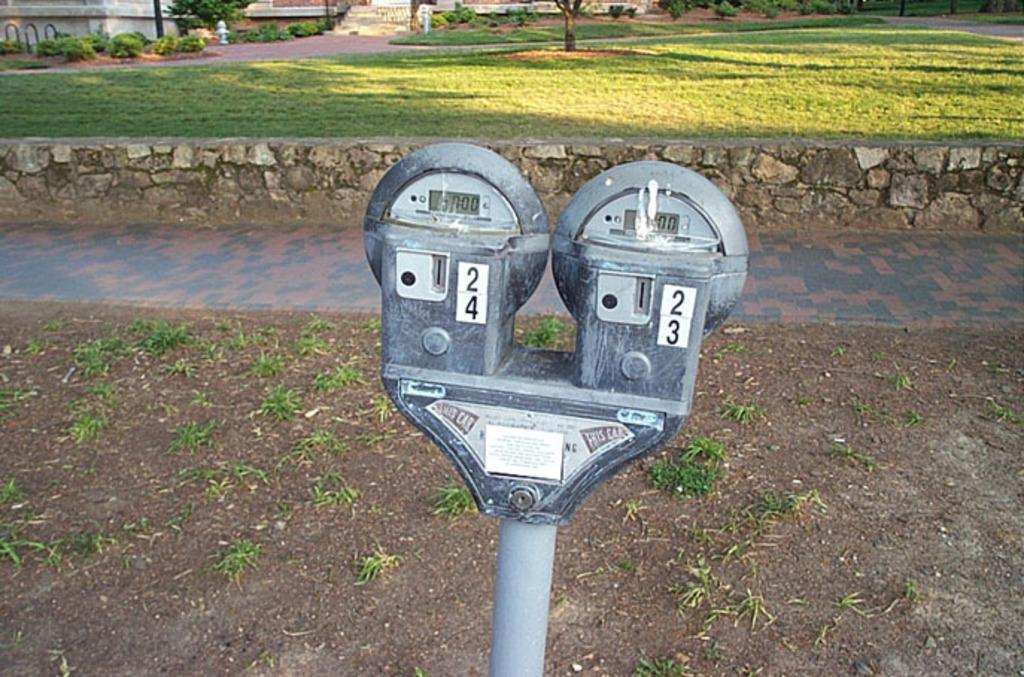Provide a one-sentence caption for the provided image. Two parking meters, one that has 24 on it and the other has 23 on it. 